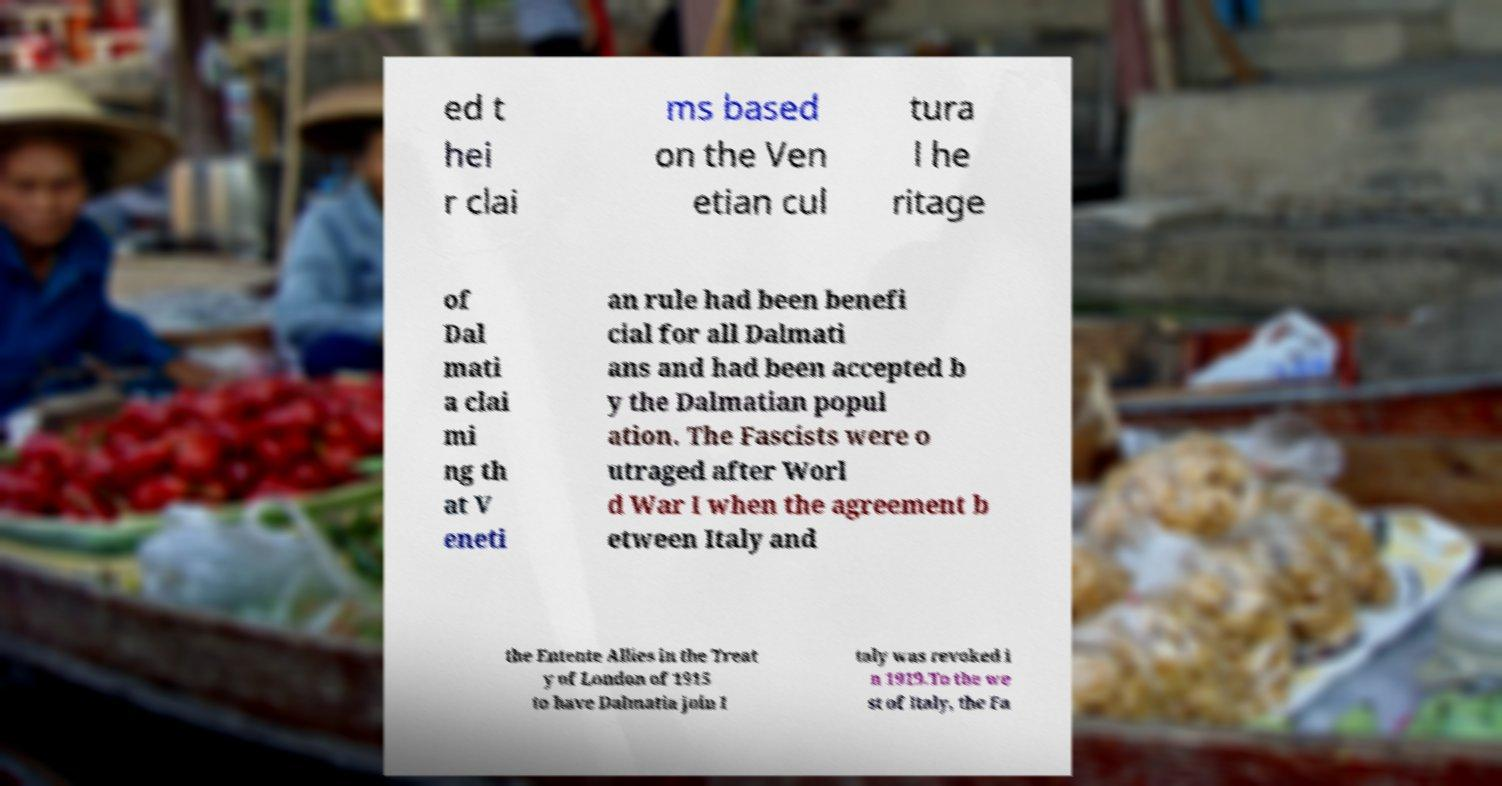There's text embedded in this image that I need extracted. Can you transcribe it verbatim? ed t hei r clai ms based on the Ven etian cul tura l he ritage of Dal mati a clai mi ng th at V eneti an rule had been benefi cial for all Dalmati ans and had been accepted b y the Dalmatian popul ation. The Fascists were o utraged after Worl d War I when the agreement b etween Italy and the Entente Allies in the Treat y of London of 1915 to have Dalmatia join I taly was revoked i n 1919.To the we st of Italy, the Fa 